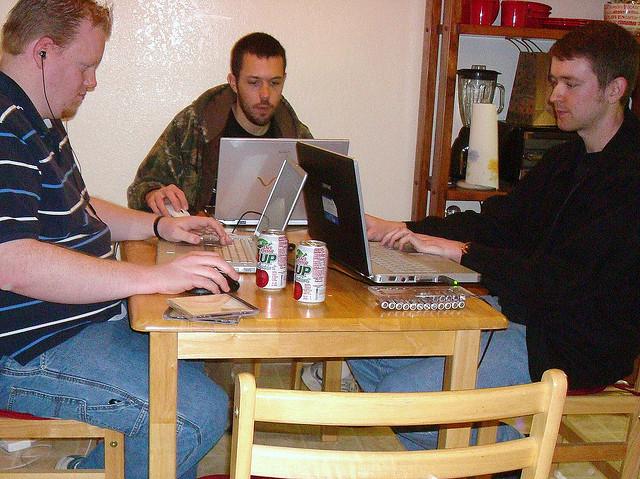What brand name is on the soda cans?
Give a very brief answer. 7 up. How many chairs are around the table?
Be succinct. 4. Does everyone have a laptop in front of him?
Keep it brief. Yes. 